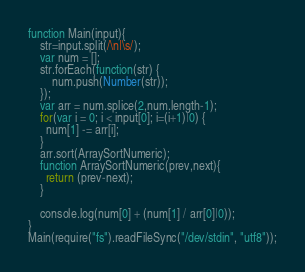<code> <loc_0><loc_0><loc_500><loc_500><_JavaScript_>function Main(input){
	str=input.split(/\n|\s/);
  	var num = [];
	str.forEach(function(str) {
        num.push(Number(str));
    });
	var arr = num.splice(2,num.length-1);
	for(var i = 0; i < input[0]; i=(i+1)|0) {
      num[1] -= arr[i];
    }
	arr.sort(ArraySortNumeric);
	function ArraySortNumeric(prev,next){
      return (prev-next);
    }

	console.log(num[0] + (num[1] / arr[0]|0));
}
Main(require("fs").readFileSync("/dev/stdin", "utf8"));</code> 